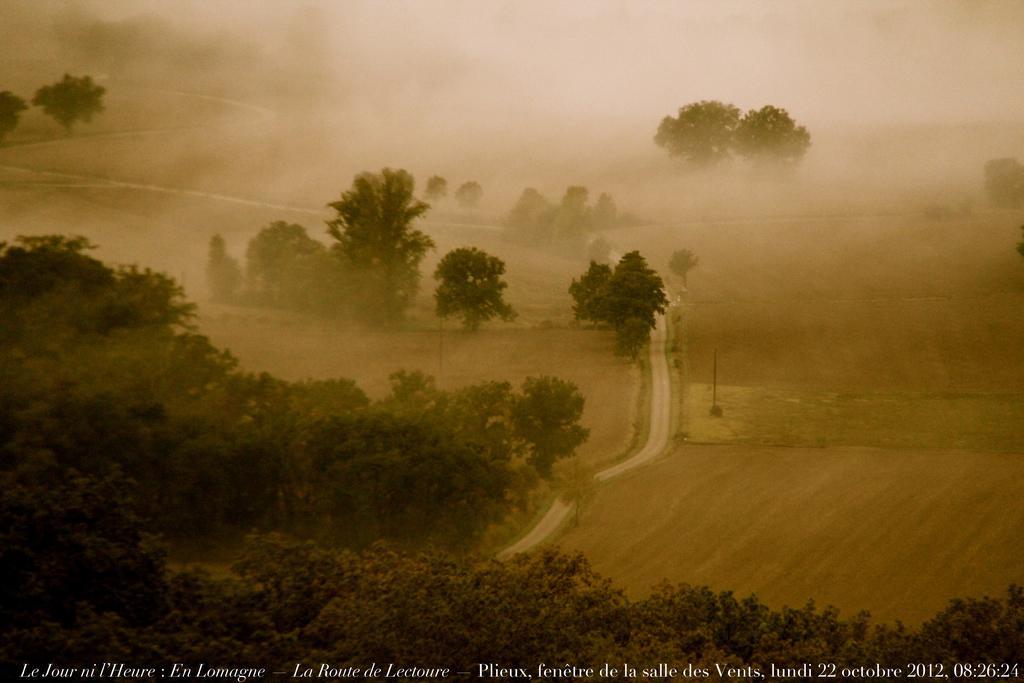How would you summarize this image in a sentence or two? At the bottom of the picture, we see the trees. On the right side, we see the sand or soil. In the middle, we see the pathway. There are trees in the background. At the bottom, we see some text written. This might be an edited image. 